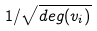<formula> <loc_0><loc_0><loc_500><loc_500>1 / \sqrt { d e g ( v _ { i } ) }</formula> 